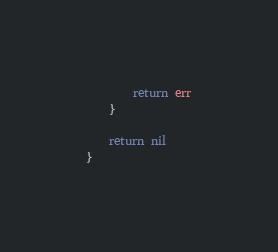Convert code to text. <code><loc_0><loc_0><loc_500><loc_500><_Go_>		return err
	}

	return nil
}
</code> 